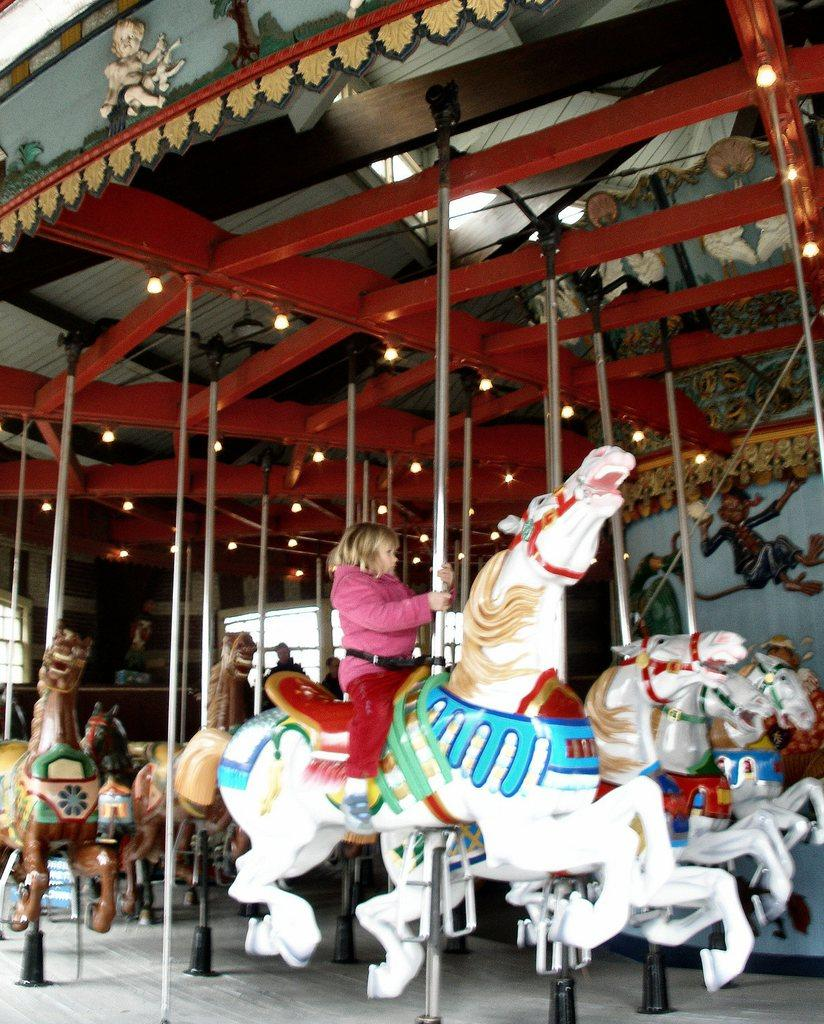What is the main subject of the image? The main subject of the image is a kid. What is the kid doing in the image? The kid is sitting on a horse toy. What else is the kid holding in the image? The kid is holding a pole. How many horse toys are visible in the image? There are multiple horse toys in the image. Where are the horse toys located in the image? The horse toys are under a roof with wooden beams. What else can be seen in the image? There are lights visible in the image. What type of body of water is visible in the image? There is no body of water present in the image. What suggestion does the kid have for improving the horse toys in the image? There is no suggestion provided by the kid in the image, as the focus is on the kid's actions and the objects present. 